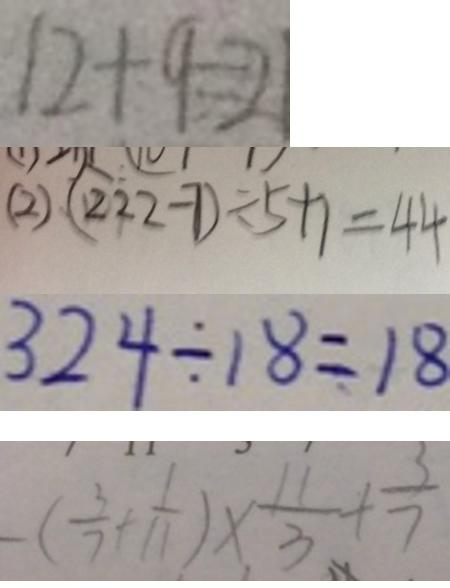<formula> <loc_0><loc_0><loc_500><loc_500>1 2 + 9 = 2 1 
 ( 2 ) ( 2 2 2 - 7 ) \div 5 + 1 = 4 4 
 3 2 4 \div 1 8 = 1 8 
 - ( \frac { 3 } { 7 } + \frac { 1 } { 1 1 } ) \times \frac { 1 1 } { 3 } + \frac { 3 } { 7 }</formula> 